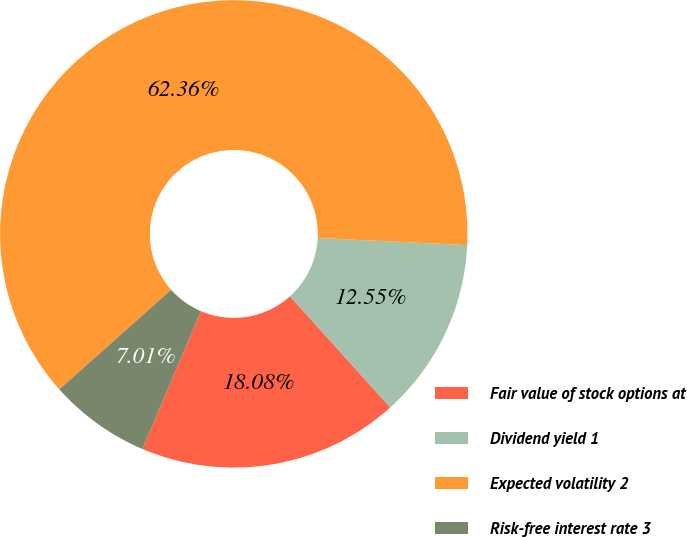Convert chart. <chart><loc_0><loc_0><loc_500><loc_500><pie_chart><fcel>Fair value of stock options at<fcel>Dividend yield 1<fcel>Expected volatility 2<fcel>Risk-free interest rate 3<nl><fcel>18.08%<fcel>12.55%<fcel>62.35%<fcel>7.01%<nl></chart> 